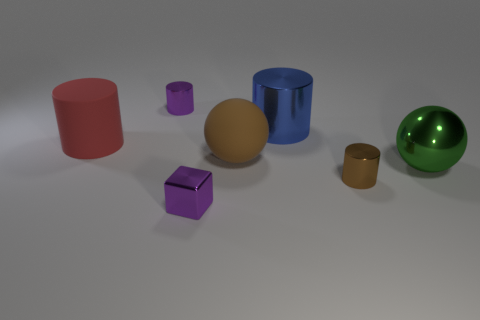Add 1 brown balls. How many objects exist? 8 Subtract all cubes. How many objects are left? 6 Subtract all tiny rubber cylinders. Subtract all shiny cubes. How many objects are left? 6 Add 6 blue shiny things. How many blue shiny things are left? 7 Add 4 large shiny cylinders. How many large shiny cylinders exist? 5 Subtract 1 green balls. How many objects are left? 6 